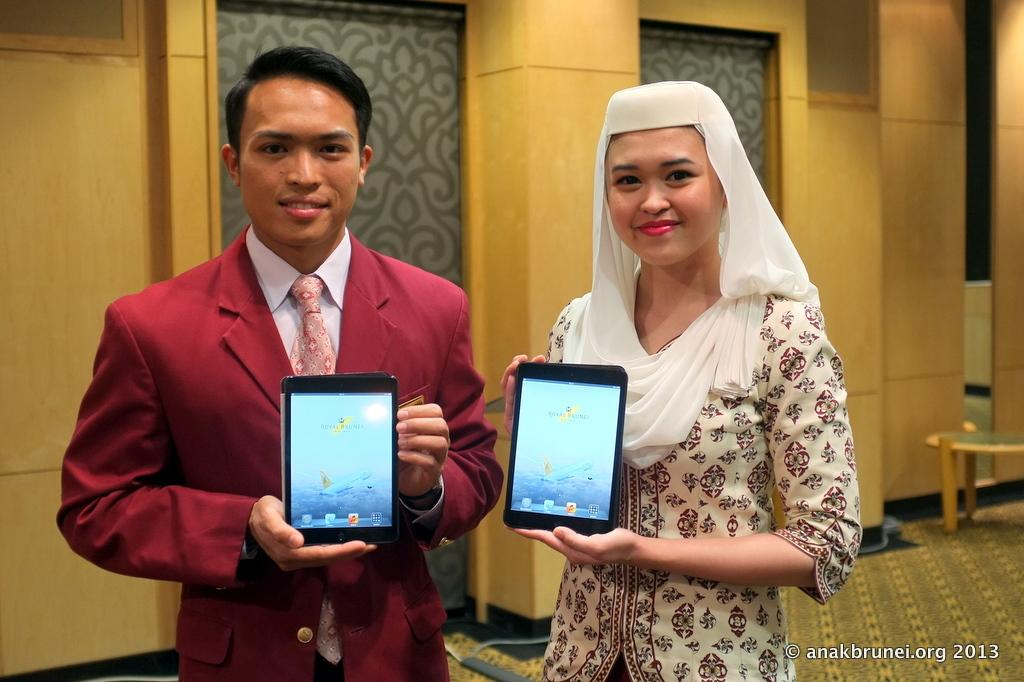How many people are in the image? There are two people in the image, a man and a woman. What are the man and the woman holding in the image? Both the man and the woman are holding an iPad. Can you describe the man's outfit in the image? The man is wearing a red suit with a tie. What accessory is the woman wearing in the image? The woman is wearing a white scarf. What piece of furniture is present in the image? There is a table in the image. What type of substance is the man creating with his toes in the image? There is no indication in the image that the man is creating any substance with his toes, nor are his toes visible in the image. 